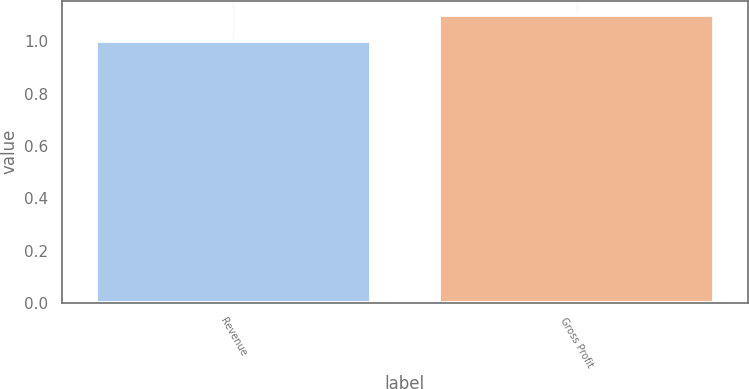Convert chart to OTSL. <chart><loc_0><loc_0><loc_500><loc_500><bar_chart><fcel>Revenue<fcel>Gross Profit<nl><fcel>1<fcel>1.1<nl></chart> 